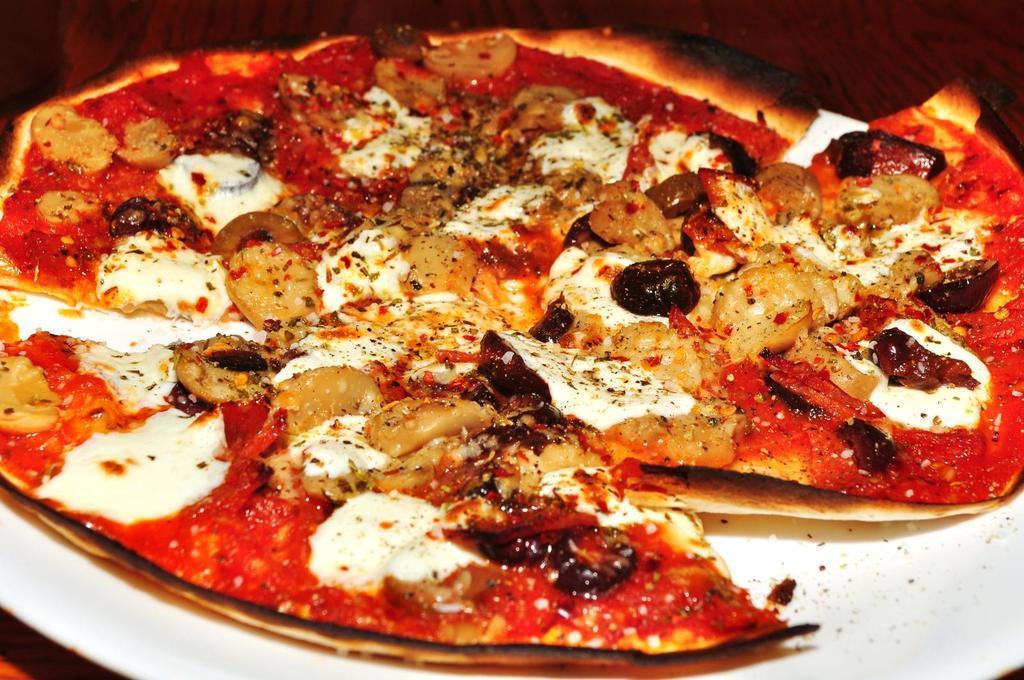Describe this image in one or two sentences. In this image at the bottom there is one plate, and in that plate there is one pizza and in the background there is a wooden table. 